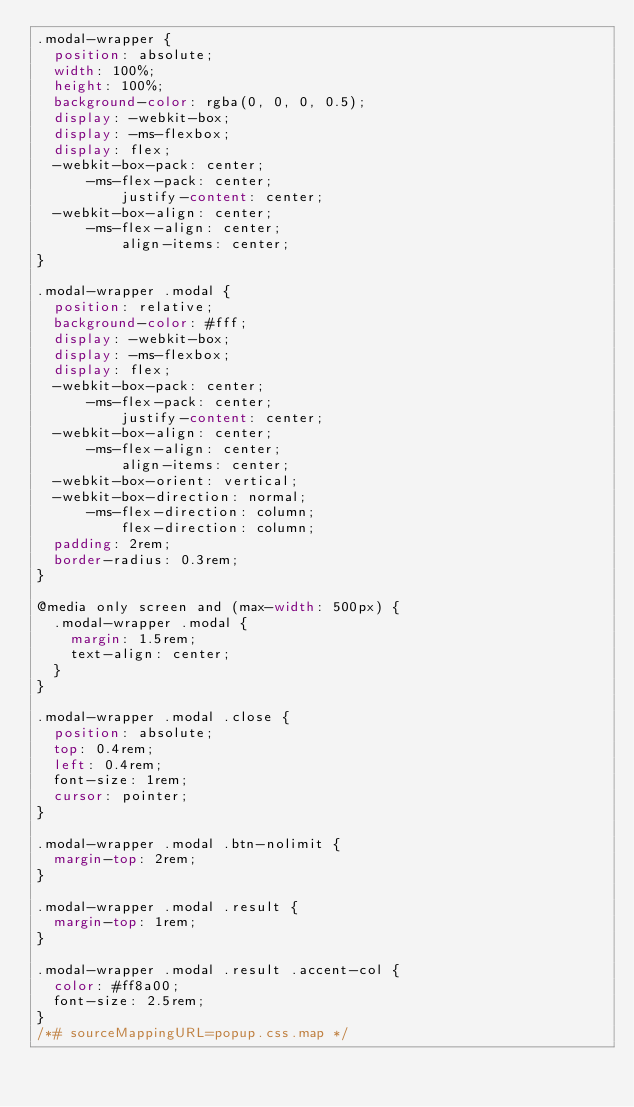<code> <loc_0><loc_0><loc_500><loc_500><_CSS_>.modal-wrapper {
  position: absolute;
  width: 100%;
  height: 100%;
  background-color: rgba(0, 0, 0, 0.5);
  display: -webkit-box;
  display: -ms-flexbox;
  display: flex;
  -webkit-box-pack: center;
      -ms-flex-pack: center;
          justify-content: center;
  -webkit-box-align: center;
      -ms-flex-align: center;
          align-items: center;
}

.modal-wrapper .modal {
  position: relative;
  background-color: #fff;
  display: -webkit-box;
  display: -ms-flexbox;
  display: flex;
  -webkit-box-pack: center;
      -ms-flex-pack: center;
          justify-content: center;
  -webkit-box-align: center;
      -ms-flex-align: center;
          align-items: center;
  -webkit-box-orient: vertical;
  -webkit-box-direction: normal;
      -ms-flex-direction: column;
          flex-direction: column;
  padding: 2rem;
  border-radius: 0.3rem;
}

@media only screen and (max-width: 500px) {
  .modal-wrapper .modal {
    margin: 1.5rem;
    text-align: center;
  }
}

.modal-wrapper .modal .close {
  position: absolute;
  top: 0.4rem;
  left: 0.4rem;
  font-size: 1rem;
  cursor: pointer;
}

.modal-wrapper .modal .btn-nolimit {
  margin-top: 2rem;
}

.modal-wrapper .modal .result {
  margin-top: 1rem;
}

.modal-wrapper .modal .result .accent-col {
  color: #ff8a00;
  font-size: 2.5rem;
}
/*# sourceMappingURL=popup.css.map */</code> 